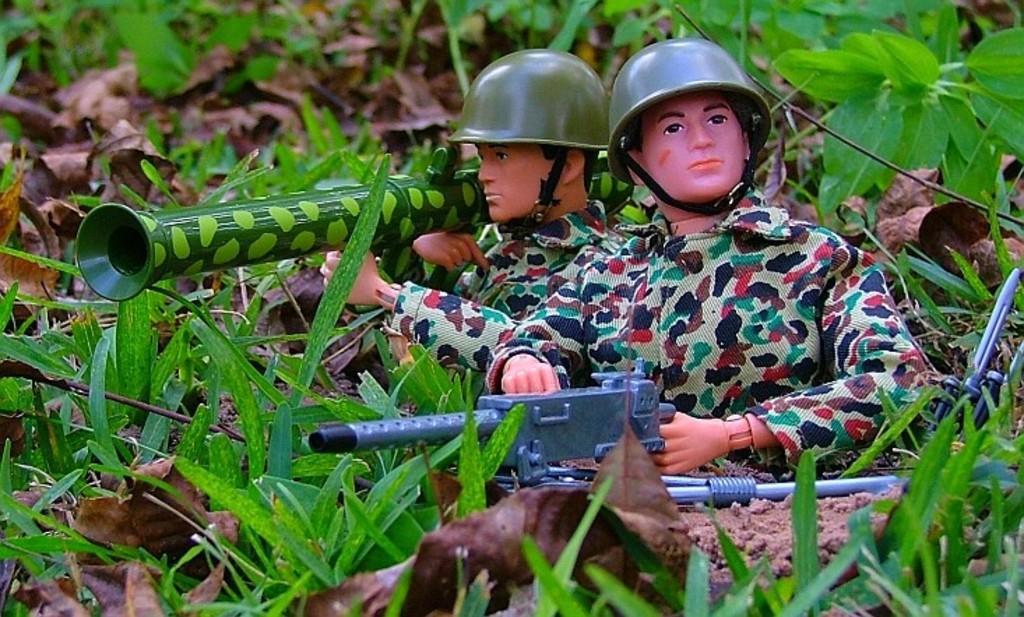Please provide a concise description of this image. This is the picture of two dolls holding some guns and around there are some plants, leaves and sand on the floor. 